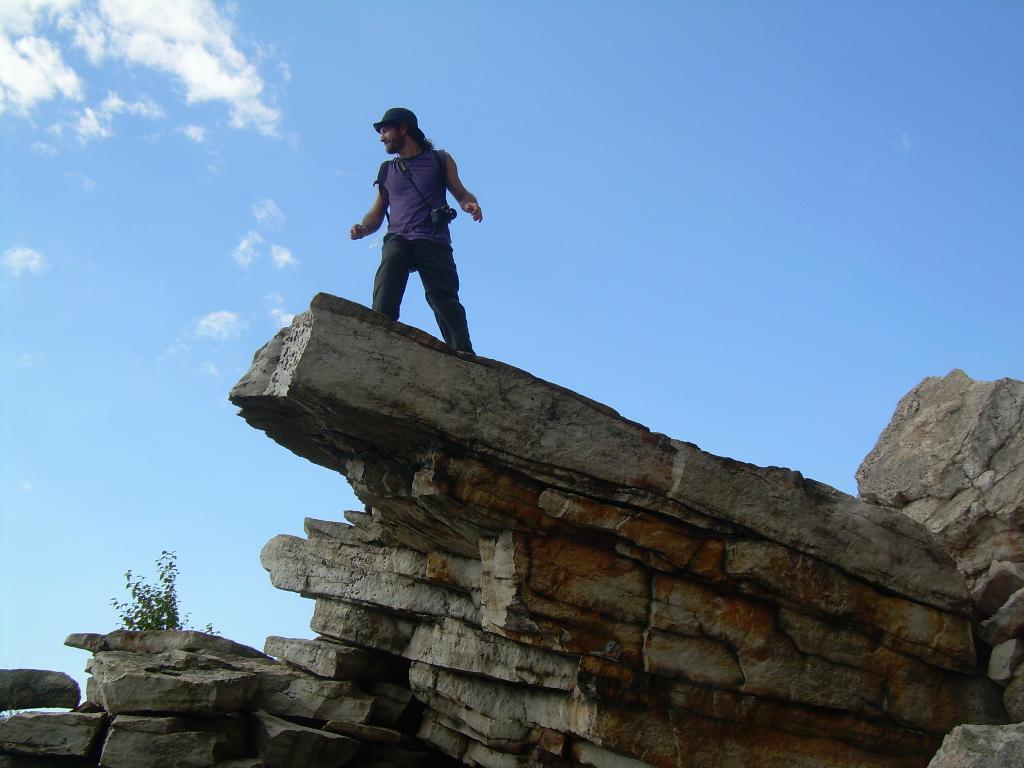In one or two sentences, can you explain what this image depicts? In this image we can see a person standing and wearing a camera, there are some rocks and a plant, in the background we can see the sky with clouds. 